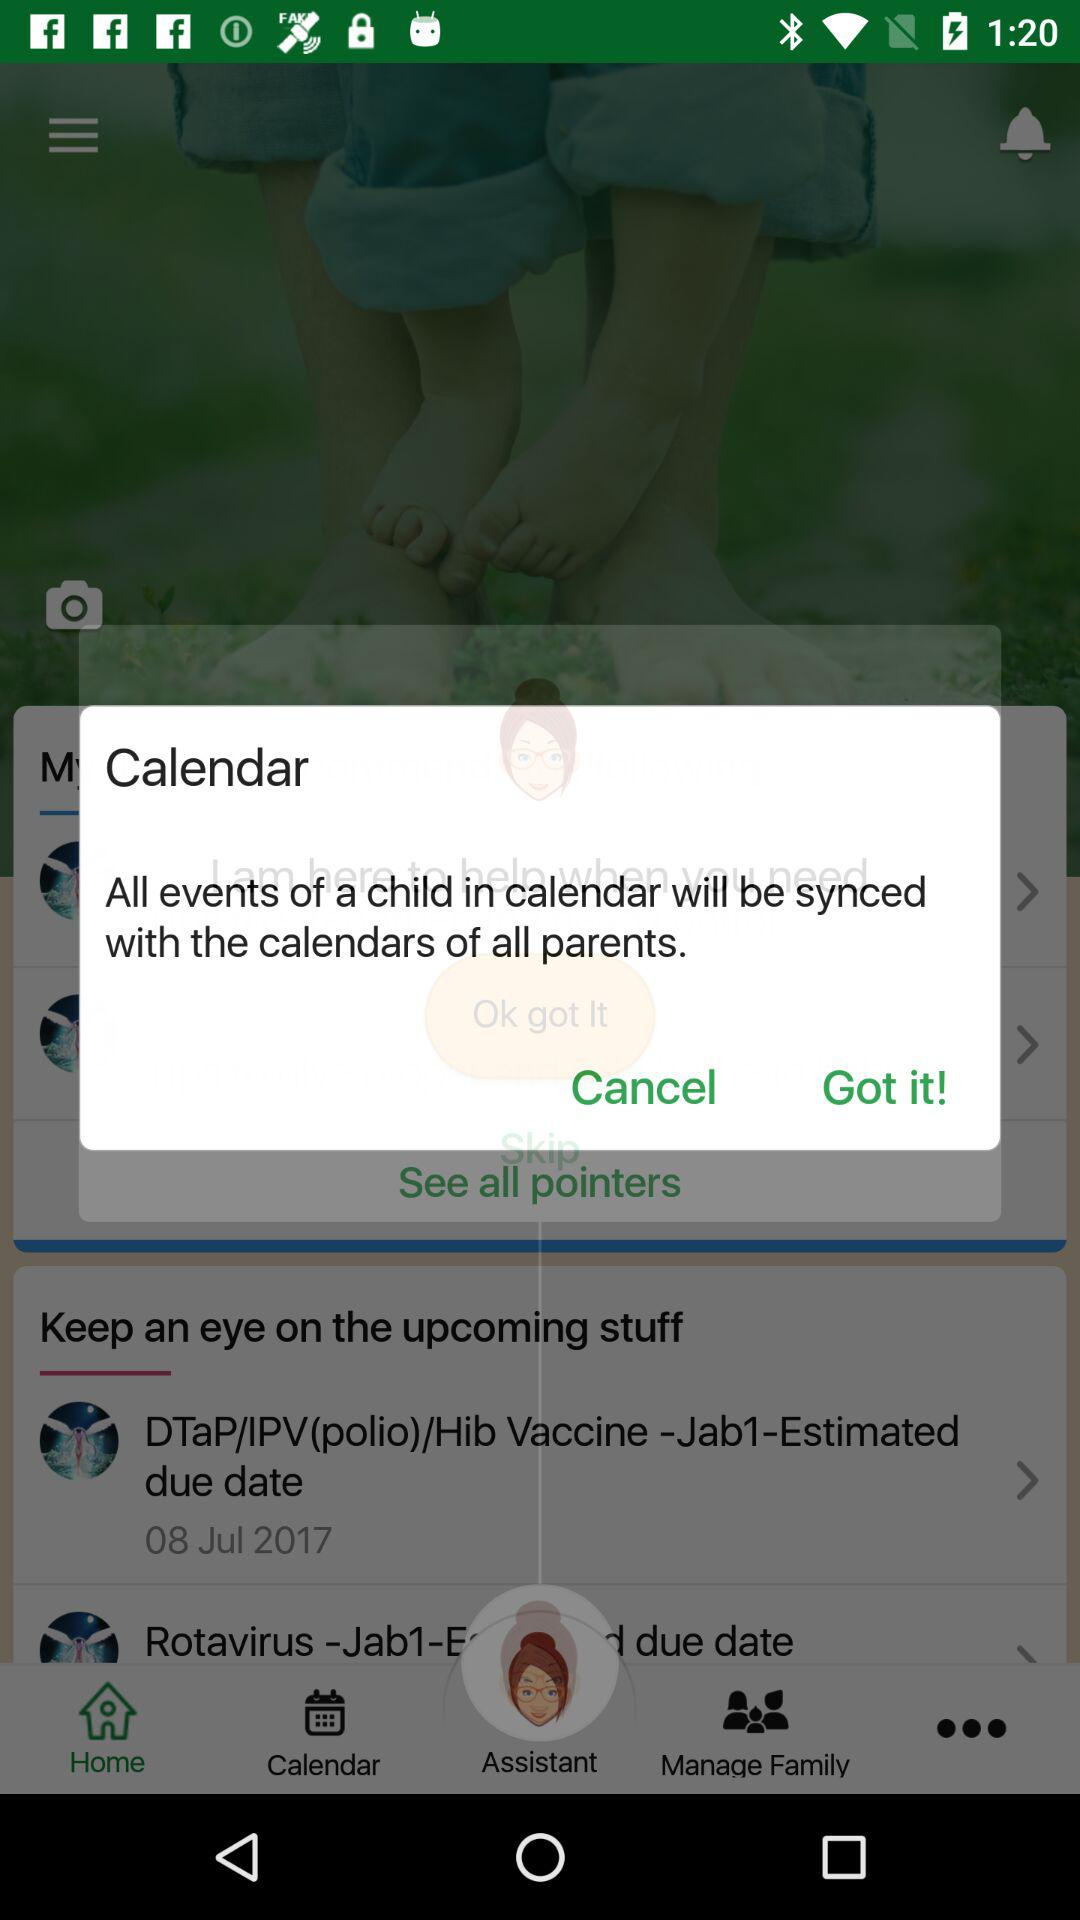What is the application name?
When the provided information is insufficient, respond with <no answer>. <no answer> 